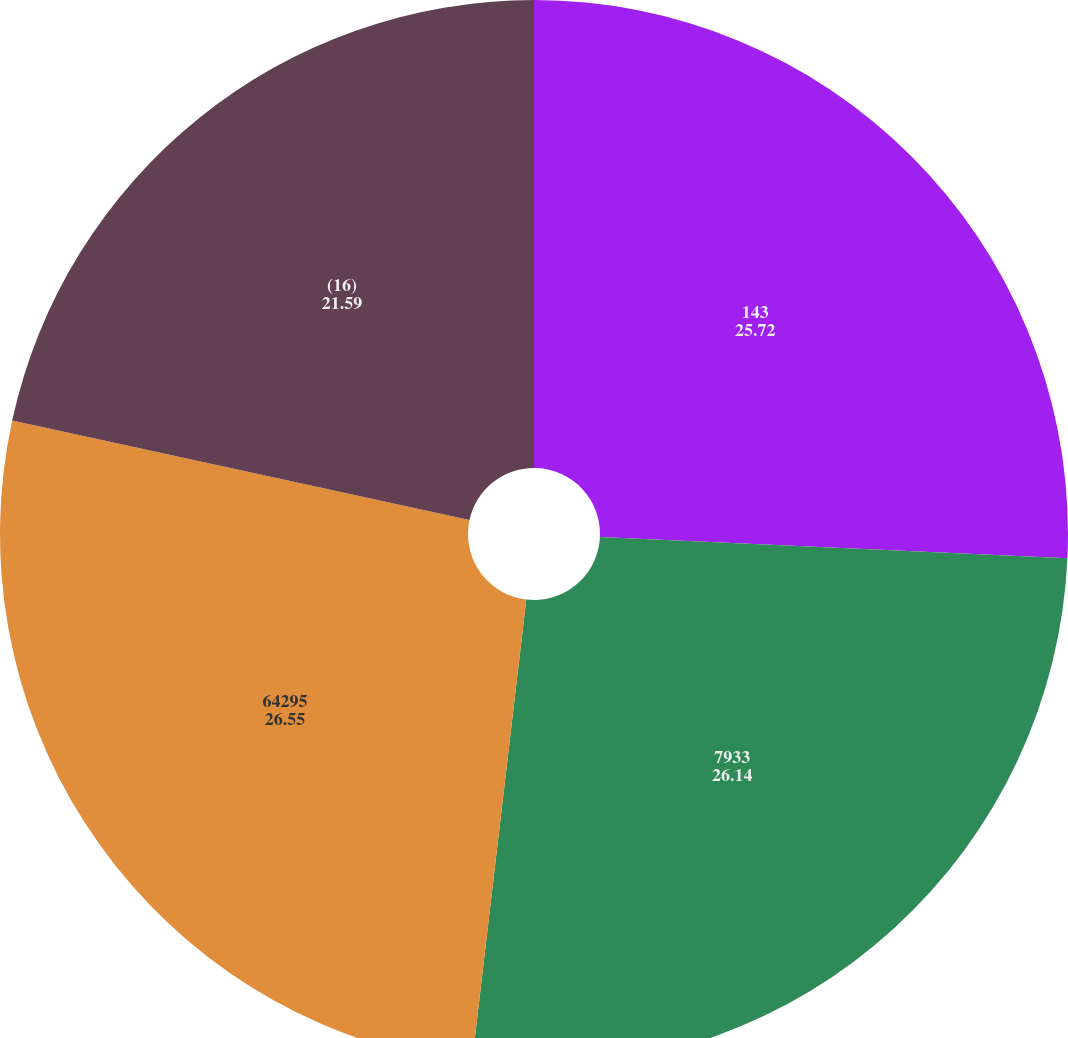Convert chart to OTSL. <chart><loc_0><loc_0><loc_500><loc_500><pie_chart><fcel>143<fcel>7933<fcel>64295<fcel>(16)<nl><fcel>25.72%<fcel>26.14%<fcel>26.55%<fcel>21.59%<nl></chart> 